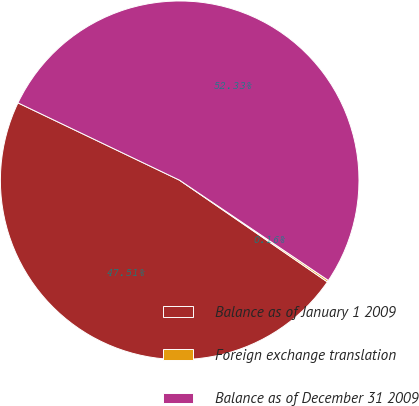Convert chart to OTSL. <chart><loc_0><loc_0><loc_500><loc_500><pie_chart><fcel>Balance as of January 1 2009<fcel>Foreign exchange translation<fcel>Balance as of December 31 2009<nl><fcel>47.51%<fcel>0.16%<fcel>52.33%<nl></chart> 